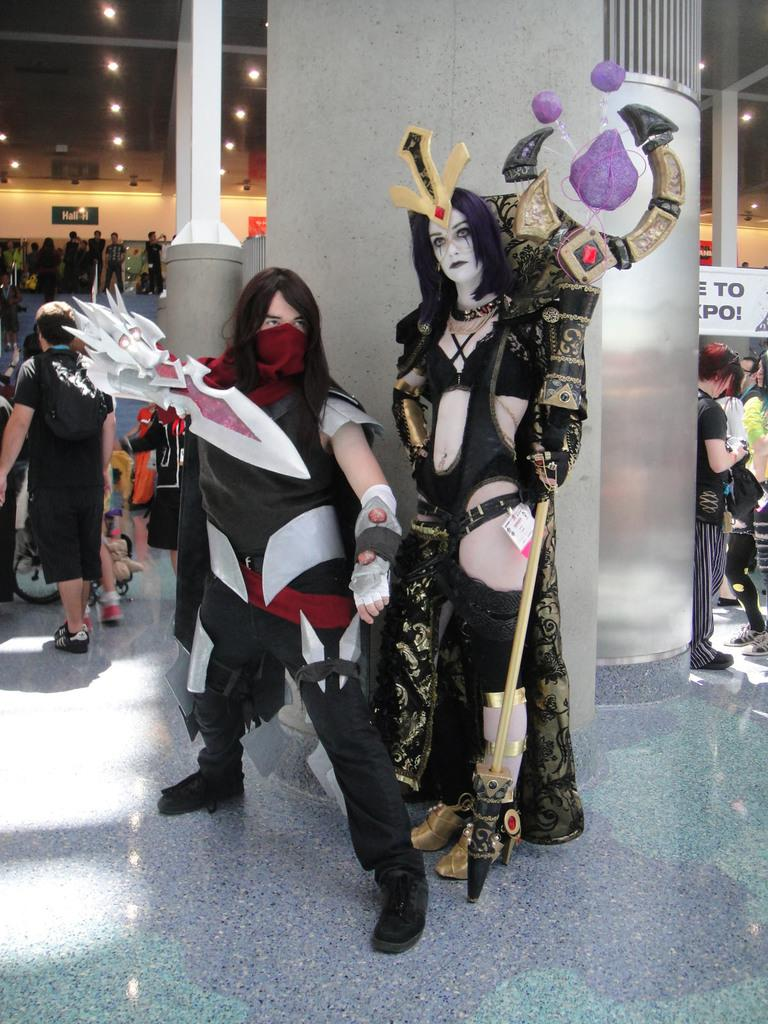What are the main subjects in the center of the image? There are persons standing in the center of the image. What can be seen in the background of the image? There are pillars, other persons, stairs, and lights in the background of the image. What type of sail is visible in the image? There is no sail present in the image. Whose birthday is being celebrated in the image? There is no indication of a birthday celebration in the image. 